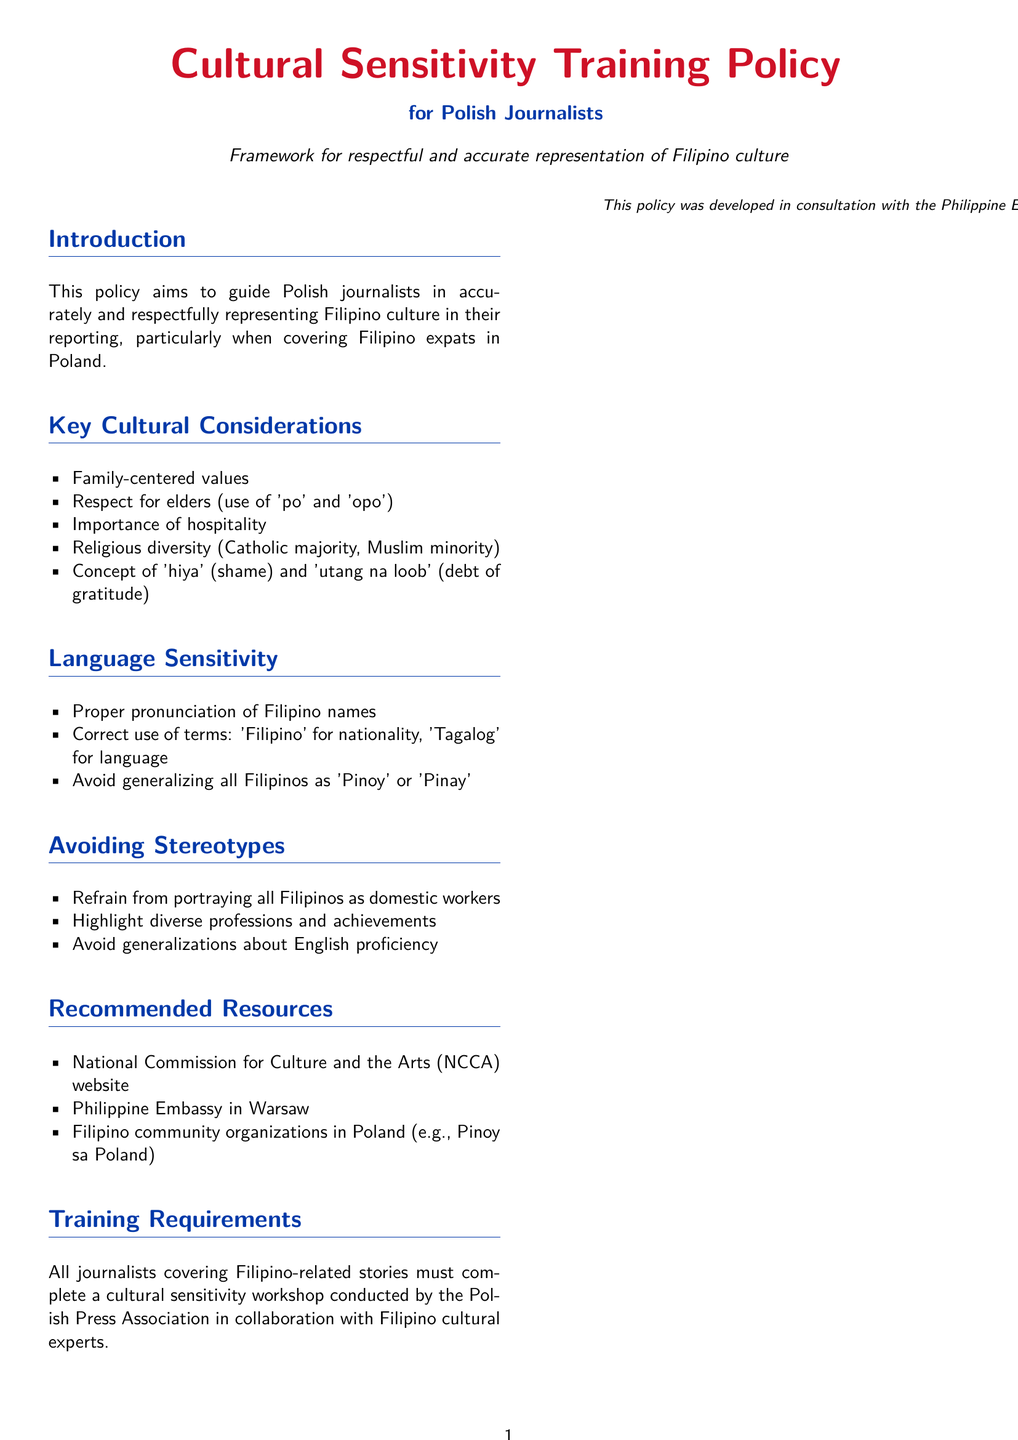What is the purpose of the policy? The purpose of the policy is to guide Polish journalists in accurately and respectfully representing Filipino culture.
Answer: Guide Polish journalists What are the key cultural considerations? The document lists several key cultural considerations under a specific section.
Answer: Family-centered values, respect for elders, importance of hospitality, religious diversity, concept of 'hiya' and 'utang na loob' Who must complete the cultural sensitivity workshop? The training requirements state that all journalists covering specific stories must complete this workshop.
Answer: All journalists What is the main religious demographic mentioned? The document indicates the predominant religious demographic among Filipinos.
Answer: Catholic majority Which organization's website is recommended as a resource? The recommended resources include a specific cultural organization's website.
Answer: National Commission for Culture and the Arts (NCCA) What term should not be generalized to all Filipinos? The document advises against using a broad term for all Filipinos.
Answer: Pinoy or Pinay How was this policy developed? The document notes the consultations involved in the development of the policy.
Answer: Consultation with the Philippine Embassy and Polish-Filipino Friendship Association What color represents the title of the document? The title of the document is visually represented in a specific color.
Answer: Filipinoblue 